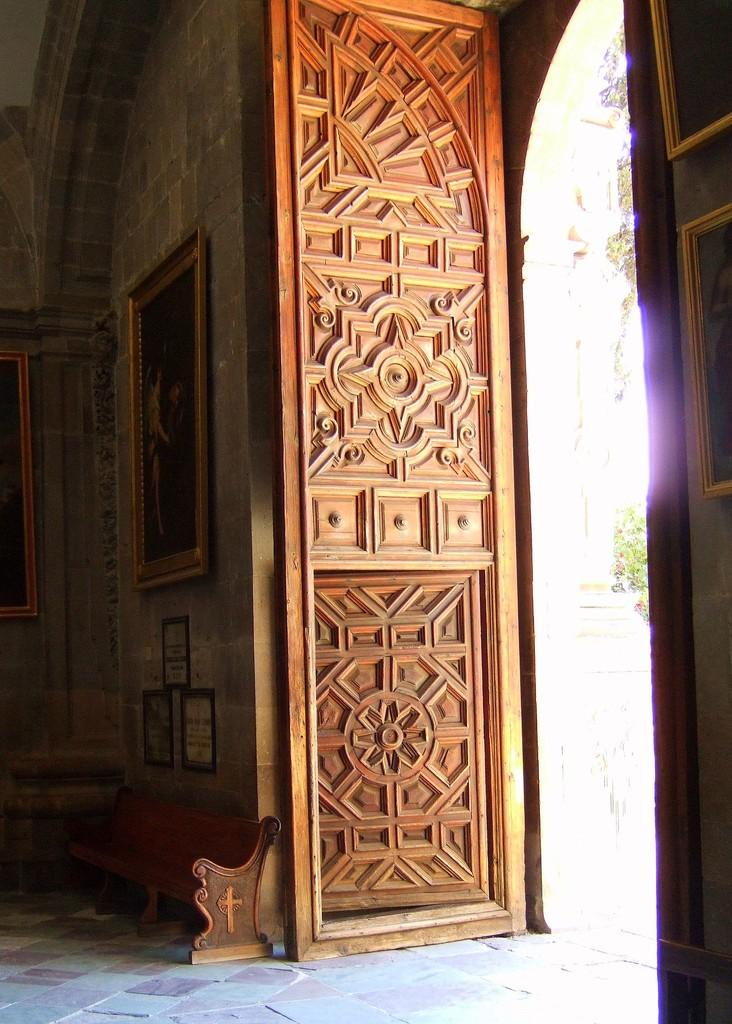What is the main subject of the image? The main subject of the image is the door of a building. What can be seen inside the building? Inside the building, there are frames attached to the wall and a bench. What is visible outside the building? Outside the building, there is a tree visible. What type of news can be heard coming from the territory outside the building? There is no reference to news or territory in the image, so it's not possible to determine what news might be heard. 